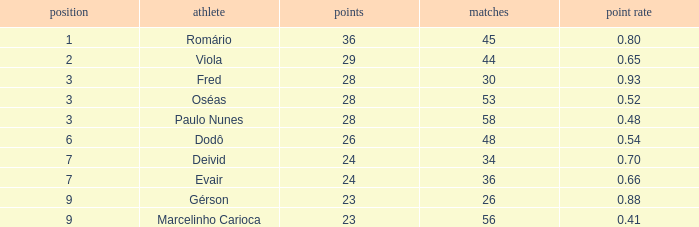What is the maximum amount of goals in rank above 3 with a goal ratio of 26.0. 